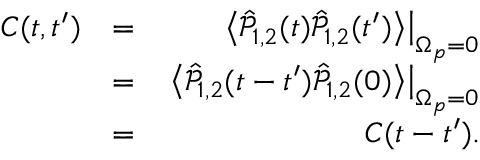Convert formula to latex. <formula><loc_0><loc_0><loc_500><loc_500>\begin{array} { r l r } { C ( t , t ^ { \prime } ) } & { = } & { \left < \hat { \mathcal { P } } _ { 1 , 2 } ( t ) \hat { \mathcal { P } } _ { 1 , 2 } ( t ^ { \prime } ) \right > \right | _ { \Omega _ { p } = 0 } } \\ & { = } & { \left < \hat { \mathcal { P } } _ { 1 , 2 } ( t - t ^ { \prime } ) \hat { \mathcal { P } } _ { 1 , 2 } ( 0 ) \right > \right | _ { \Omega _ { p } = 0 } } \\ & { = } & { C ( t - t ^ { \prime } ) . } \end{array}</formula> 